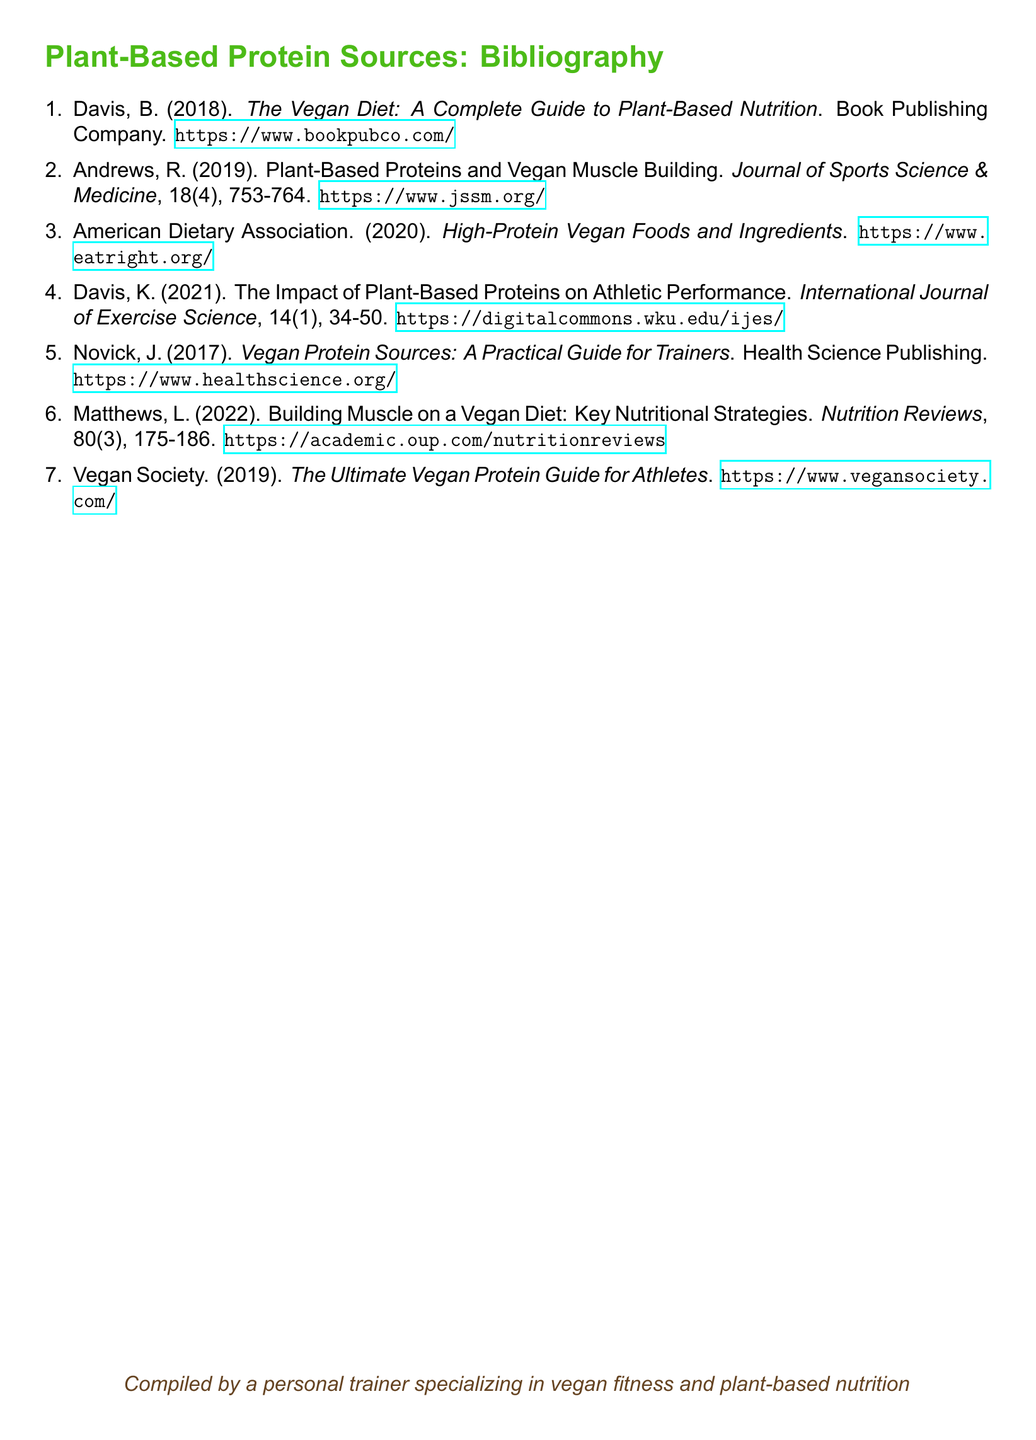What is the title of the first item in the bibliography? The title is found in the first entry of the bibliography, which is "The Vegan Diet: A Complete Guide to Plant-Based Nutrition."
Answer: The Vegan Diet: A Complete Guide to Plant-Based Nutrition Who authored the article titled "Plant-Based Proteins and Vegan Muscle Building"? The author is listed at the beginning of the entry that contains the article title, which is R. Andrews.
Answer: R. Andrews In what year was "The Ultimate Vegan Protein Guide for Athletes" published? The publication year is indicated next to the title of the journal entry for the Vegan Society, which is 2019.
Answer: 2019 What type of source is "Vegan Protein Sources: A Practical Guide for Trainers"? The source type is determined by its formatting and content, which indicates it is a book.
Answer: Book How many items are listed in the bibliography? The total number is counted from the entries in the bibliography, which are seven items.
Answer: 7 What is the volume number of the article titled "Building Muscle on a Vegan Diet: Key Nutritional Strategies"? The volume number is found in the citation details of the article, which is 80.
Answer: 80 Which organization published "High-Protein Vegan Foods and Ingredients"? The publisher is identified in the entry, stating it is the American Dietary Association.
Answer: American Dietary Association What is the focus of the article by K. Davis published in 2021? The focus is revealed by the article title, which is about the impact of plant-based proteins on athletic performance.
Answer: Athletic performance 